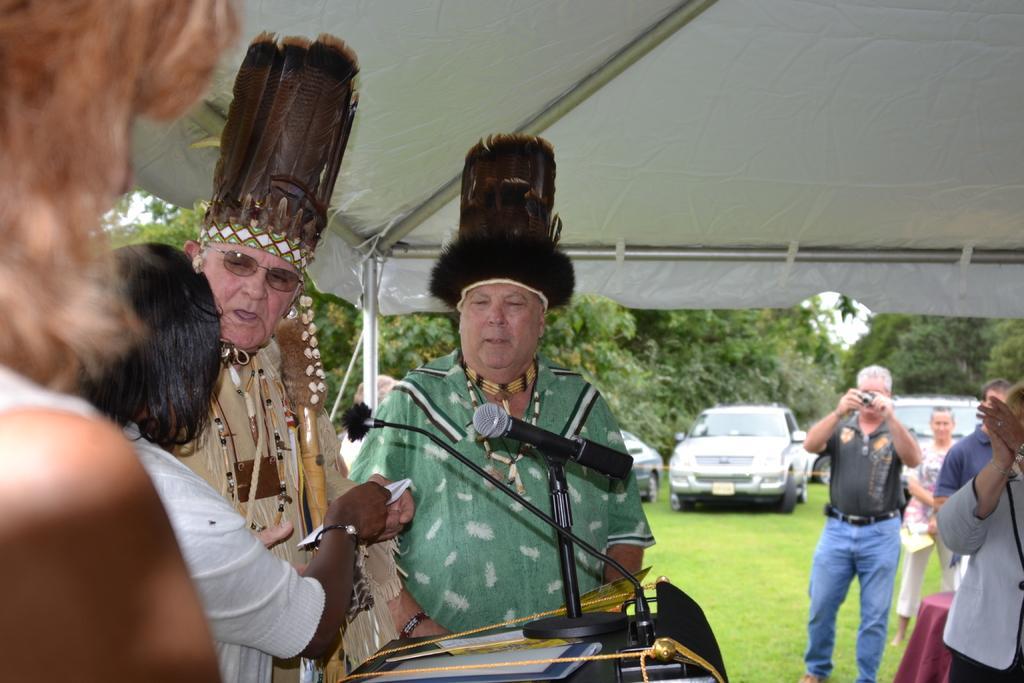In one or two sentences, can you explain what this image depicts? In this image we can see people standing. There is a mic on the podium. To the right side of the image there are people standing. At the top of the image there is white color tent with rods. In the background of the image there are trees, cars on the grass. 